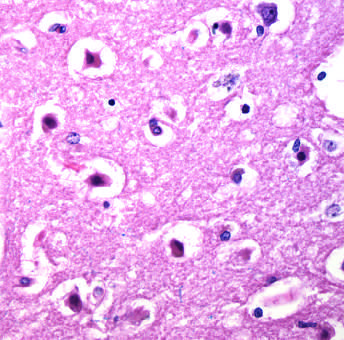how are the cell bodies?
Answer the question using a single word or phrase. Shrunken and eosinophilic 